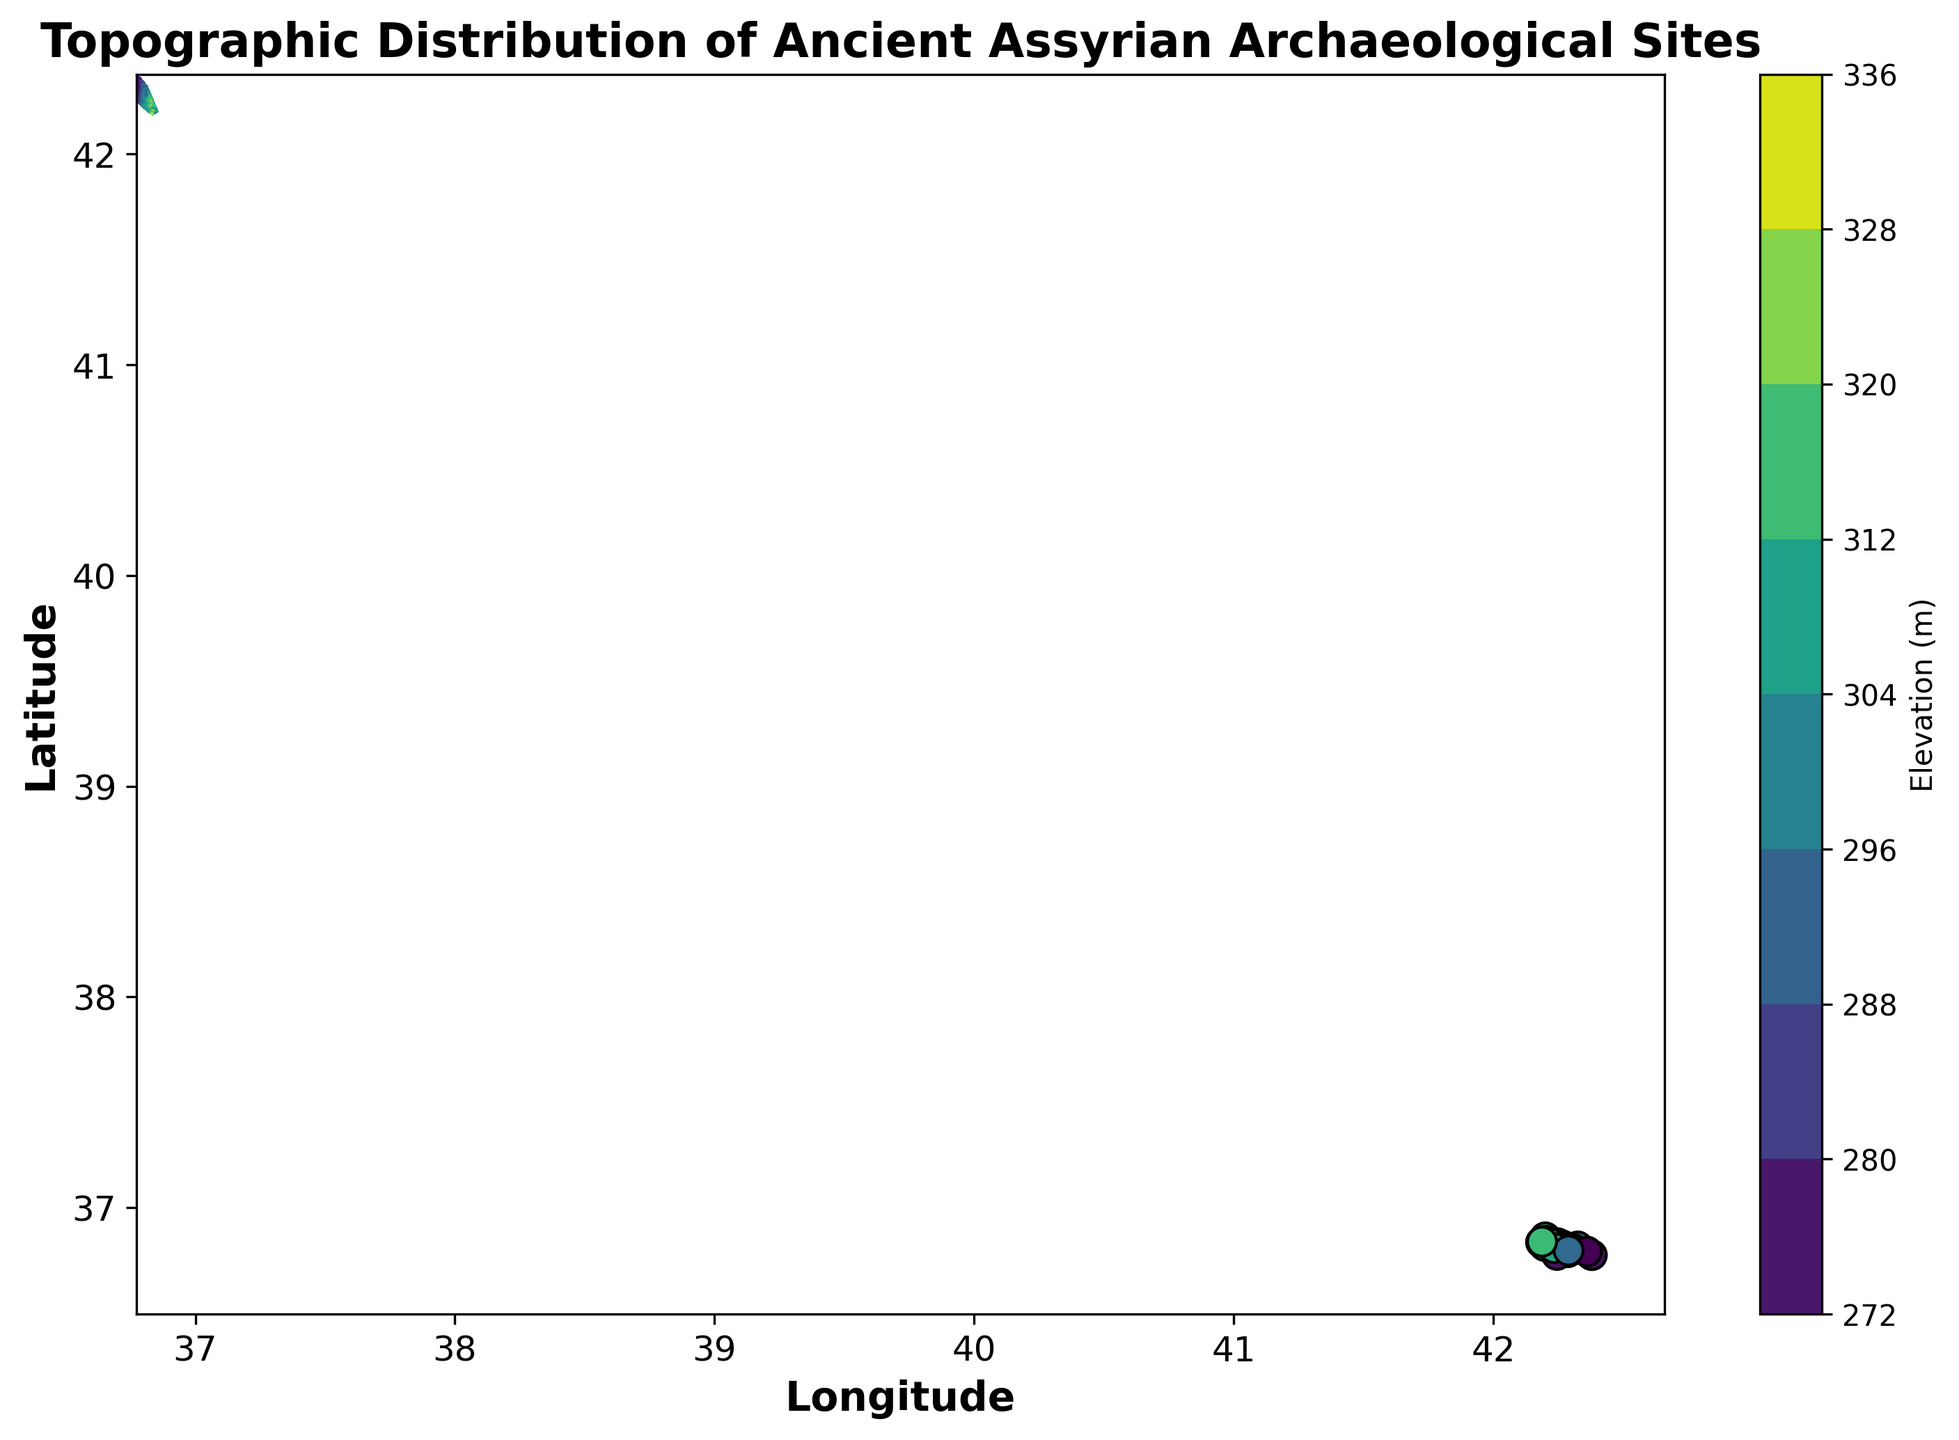What is the elevation range depicted in the contour plot? To determine the elevation range, observe the color bar, which represents the elevation in meters. The range is defined between the minimum and maximum values shown.
Answer: 278 to 325 meters Which area has the highest elevation according to the color distribution in the figure? To find the area with the highest elevation, look for the darkest colors on the contour plot, which correspond to the highest values on the color bar.
Answer: The area around (36.8365° N, 42.1910° E) and (36.8281° N, 42.1949° E) How many distinct elevation points are scatter-plotted on the contour map? To determine the number of distinct elevation points, count the individual scatter points displayed over the contour plot.
Answer: 30 Which data point has the lowest elevation, and what is its specific location? Identify the data point with the lightest color shade on the scatter plot, which corresponds to the lowest value on the color bar. Then locate its coordinates.
Answer: (36.7753° N, 42.2457° E) with 280 meters What is the average elevation of the scatter points with latitudes greater than 36.83° N? Filter the scatter points with latitudes greater than 36.83° N, sum their elevation values, and divide by the number of these points.
Answer: Average of points at (36.8308, 320), (36.8353, 305), (36.8365, 325), (36.8421, 298), (36.8410, 320), (36.8384, 310), and (36.8281, 325) results in (320 + 305 + 325 + 298 + 320 + 310 + 325)/7 = 320.43 meters Which latitude band, from 36.77° N to 36.81° N or from 36.82° N to 36.85° N, shows more variation in elevation? Compare the range and distribution of elevation points (e.g., min and max values) within the two specified latitude bands in the scatter plot.
Answer: 36.82° N to 36.85° N shows more variation with elevations from 295 to 325 meters 